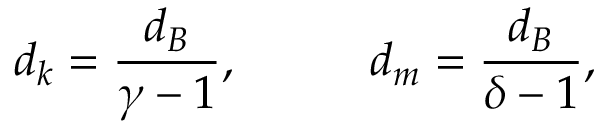Convert formula to latex. <formula><loc_0><loc_0><loc_500><loc_500>d _ { k } = \frac { d _ { B } } { \gamma - 1 } , \, d _ { m } = \frac { d _ { B } } { \delta - 1 } ,</formula> 